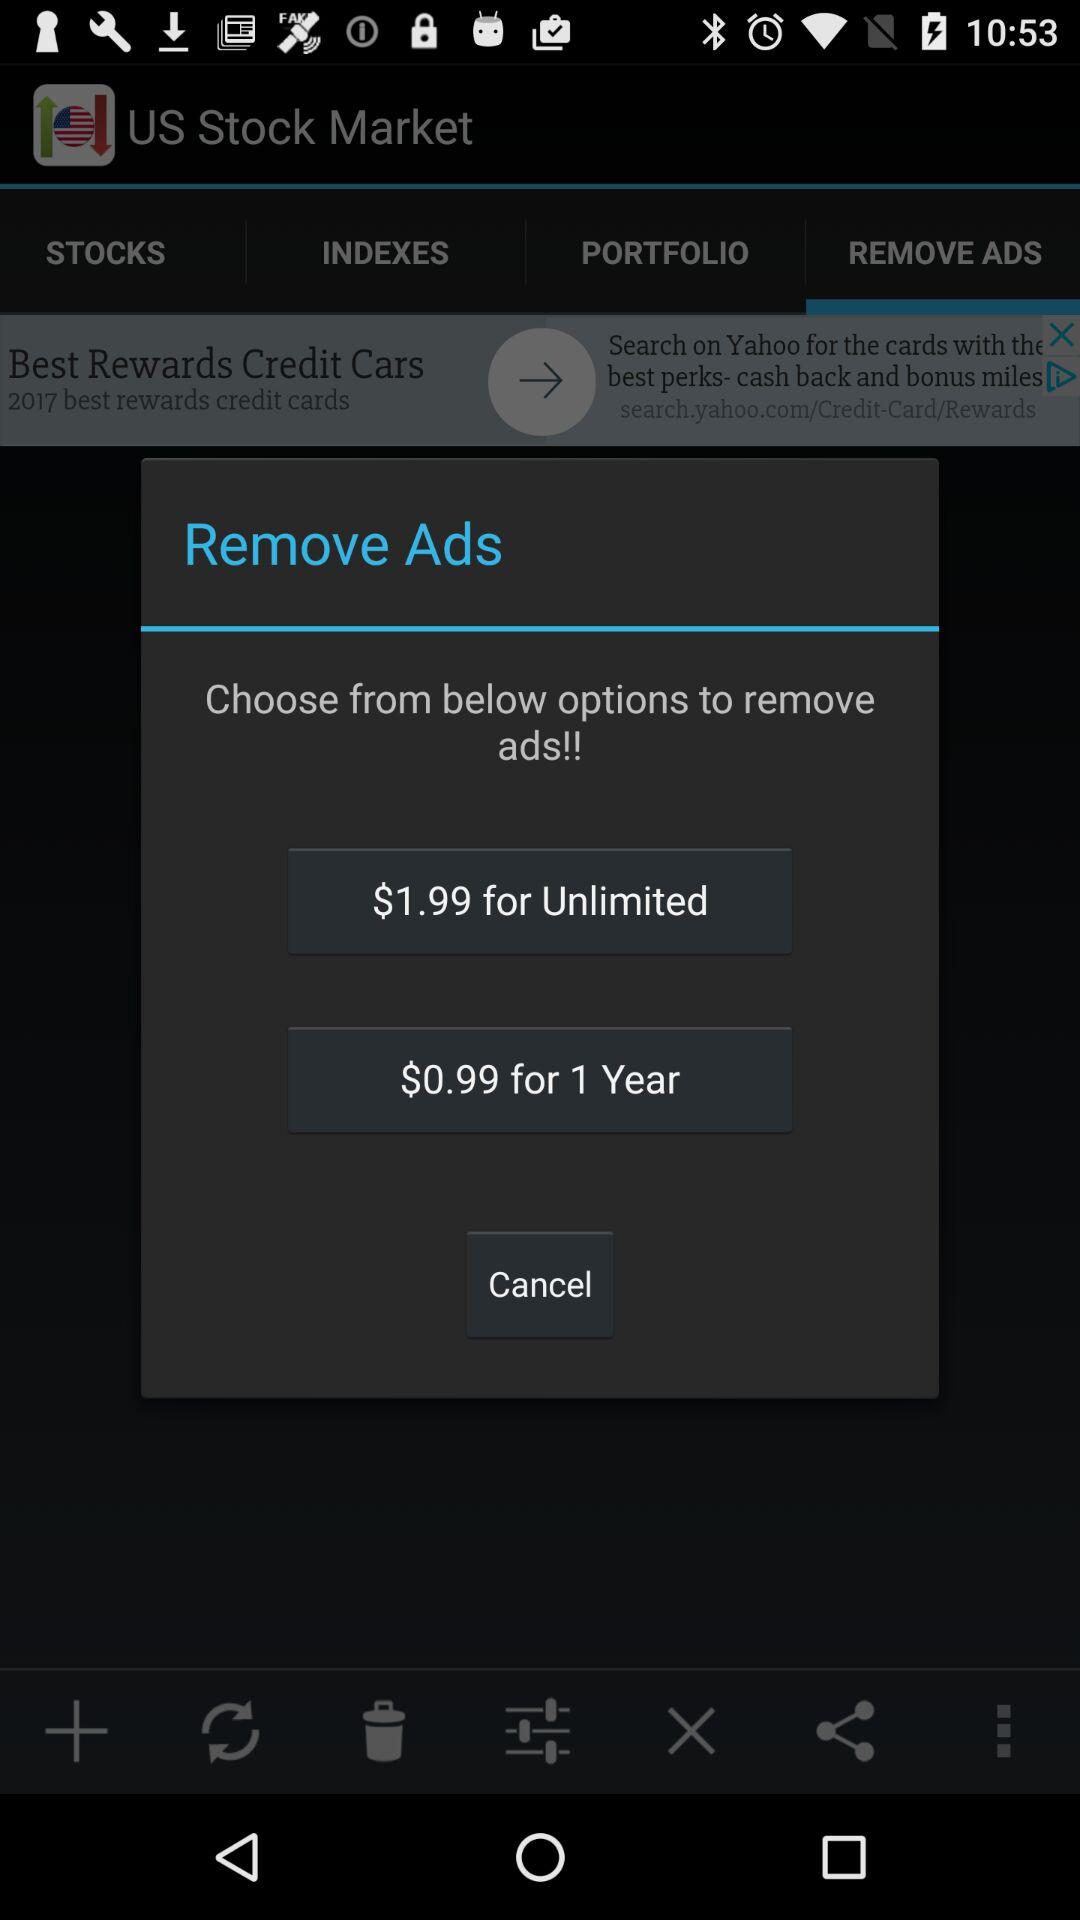What are the different options available for removing ads? The different options available for removing ads are "$1.99 for Unlimited" and "$0.99 for 1 Year". 